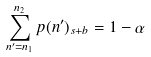<formula> <loc_0><loc_0><loc_500><loc_500>\sum _ { n ^ { \prime } = n _ { 1 } } ^ { n _ { 2 } } p ( n ^ { \prime } ) _ { s + b } = 1 - \alpha</formula> 